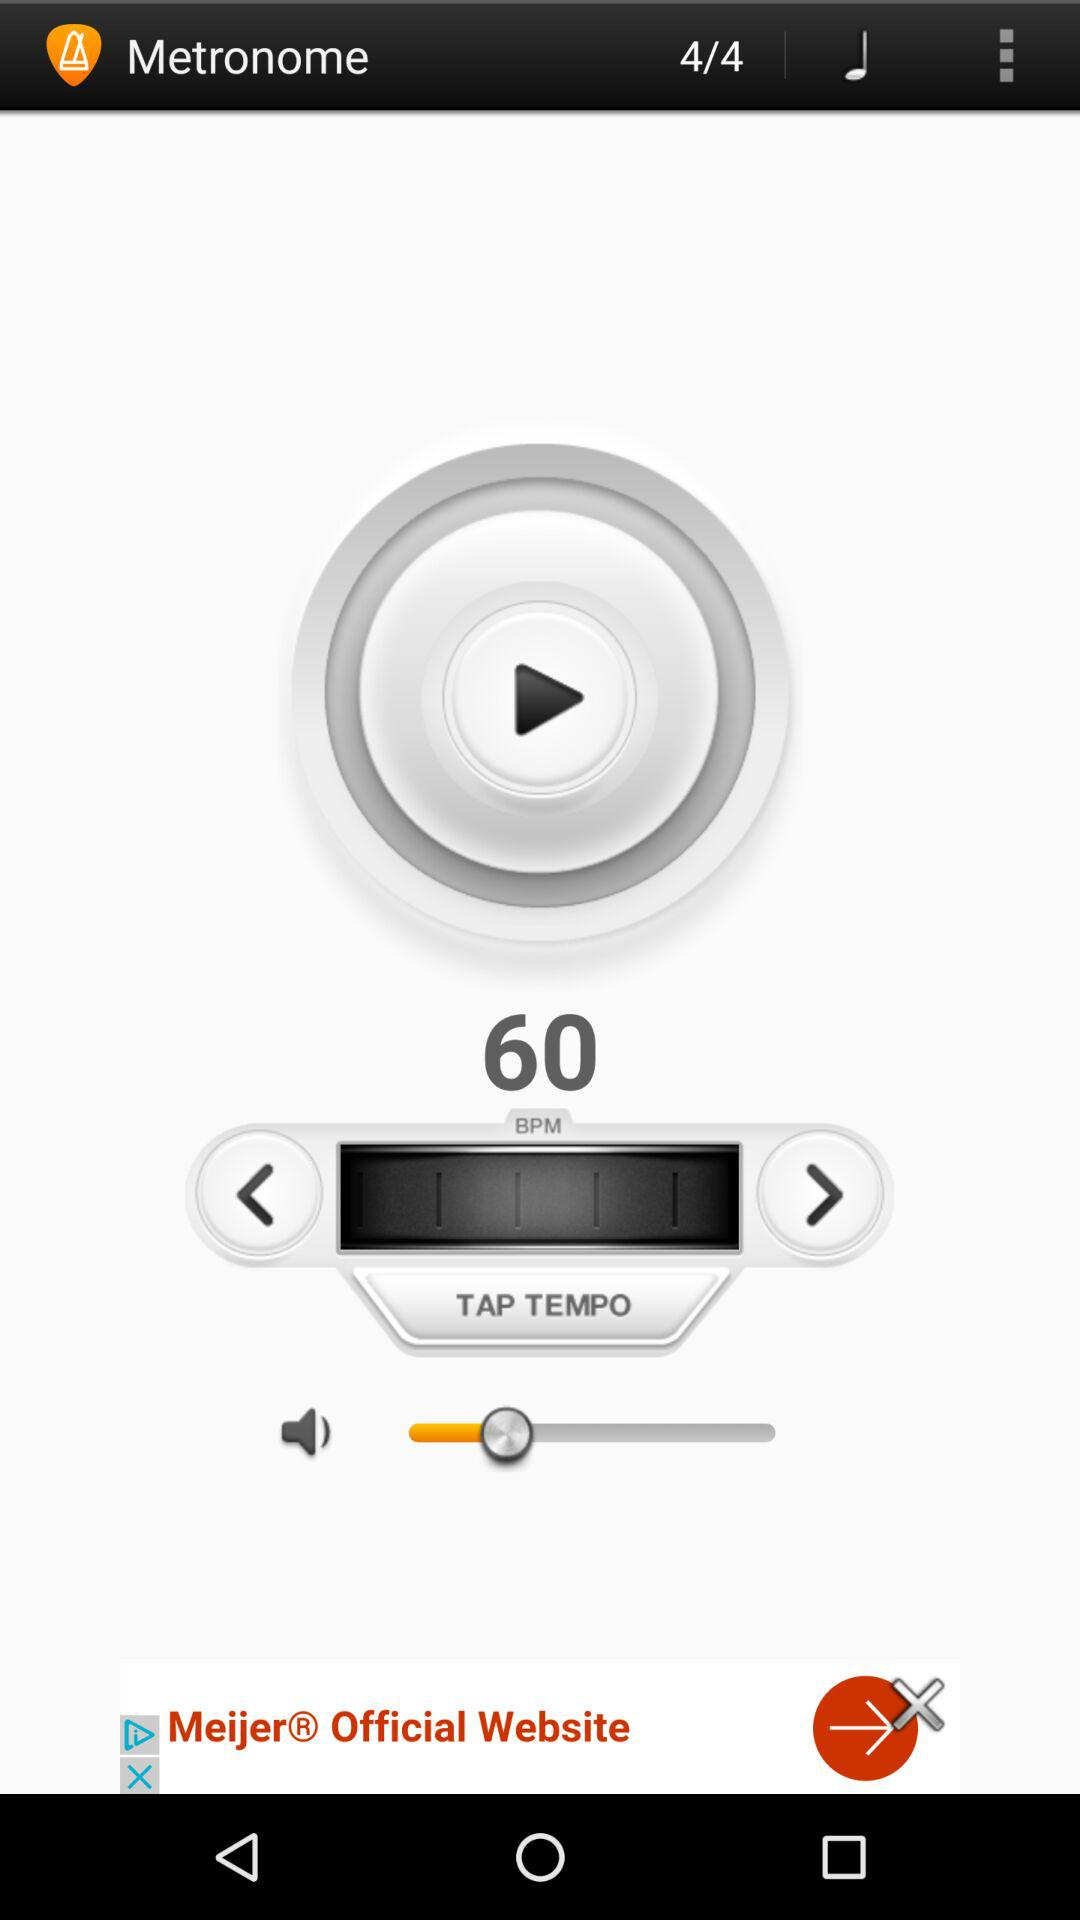What is the BPM? The BPM is 60. 